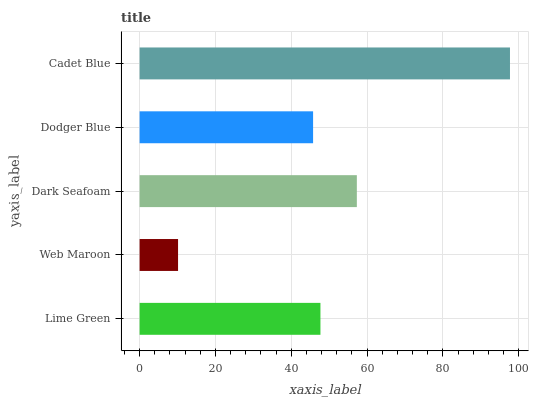Is Web Maroon the minimum?
Answer yes or no. Yes. Is Cadet Blue the maximum?
Answer yes or no. Yes. Is Dark Seafoam the minimum?
Answer yes or no. No. Is Dark Seafoam the maximum?
Answer yes or no. No. Is Dark Seafoam greater than Web Maroon?
Answer yes or no. Yes. Is Web Maroon less than Dark Seafoam?
Answer yes or no. Yes. Is Web Maroon greater than Dark Seafoam?
Answer yes or no. No. Is Dark Seafoam less than Web Maroon?
Answer yes or no. No. Is Lime Green the high median?
Answer yes or no. Yes. Is Lime Green the low median?
Answer yes or no. Yes. Is Cadet Blue the high median?
Answer yes or no. No. Is Web Maroon the low median?
Answer yes or no. No. 